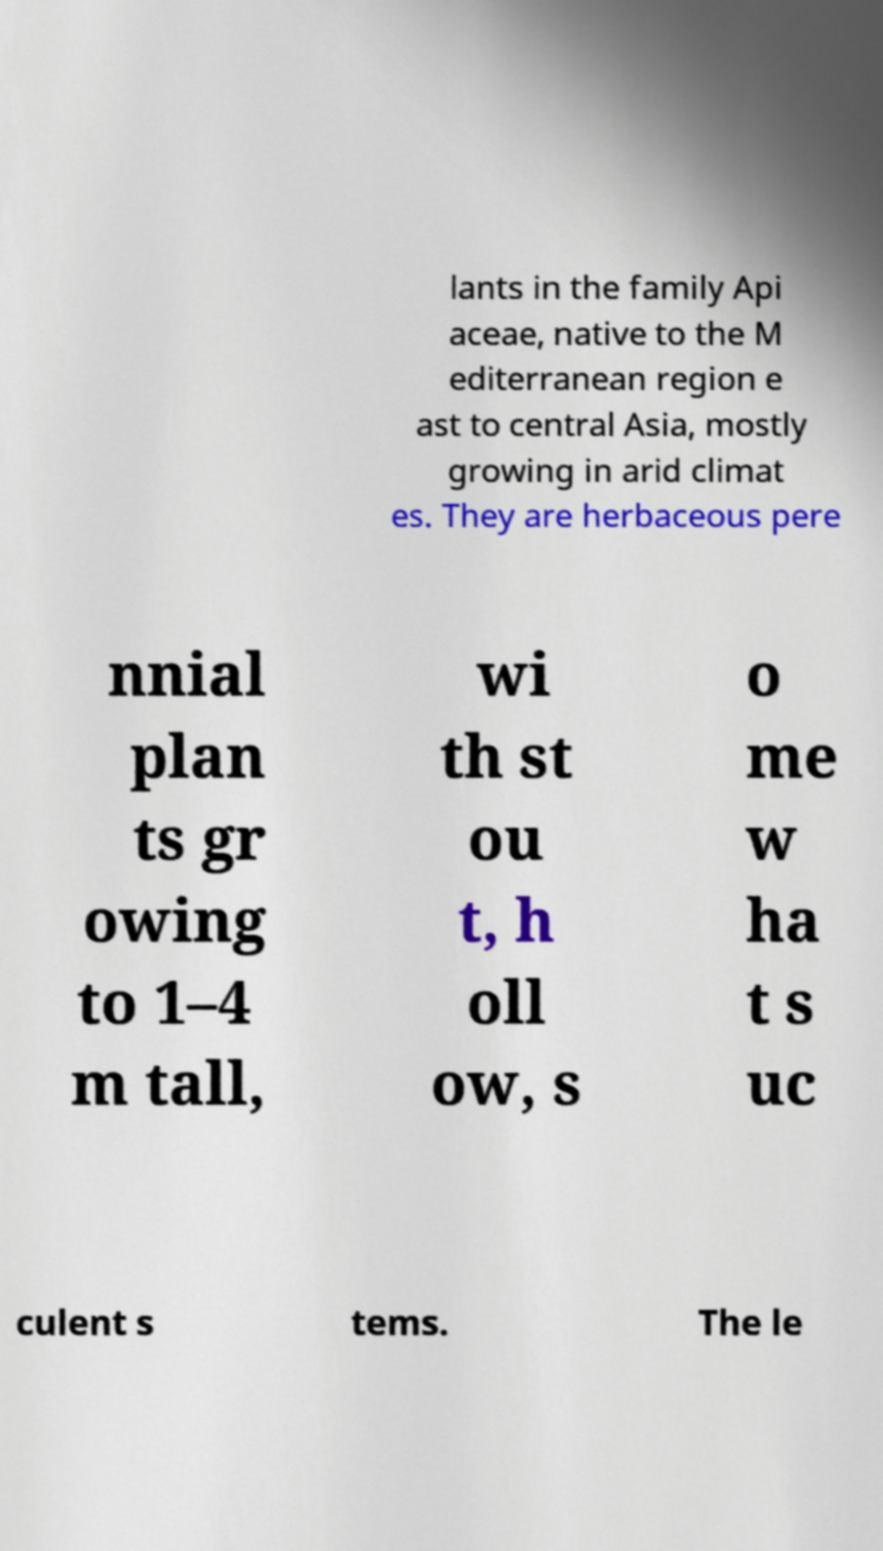Please identify and transcribe the text found in this image. lants in the family Api aceae, native to the M editerranean region e ast to central Asia, mostly growing in arid climat es. They are herbaceous pere nnial plan ts gr owing to 1–4 m tall, wi th st ou t, h oll ow, s o me w ha t s uc culent s tems. The le 